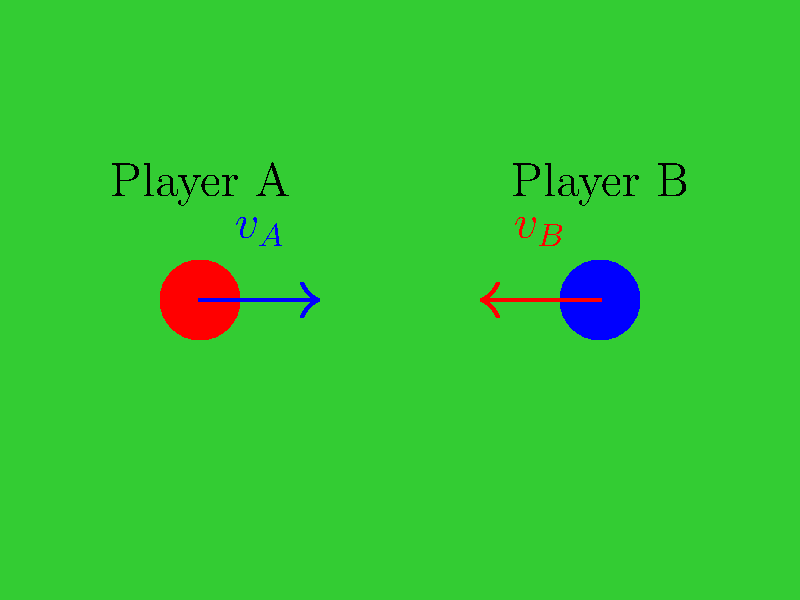Two soccer players, A and B, with masses $m_A = 70$ kg and $m_B = 80$ kg, are running towards each other on the field. Player A is moving with a velocity of $v_A = 5$ m/s to the right, while Player B is moving with a velocity of $v_B = 4$ m/s to the left. They collide and stick together. What is their combined velocity immediately after the collision? To solve this problem, we'll use the principle of conservation of momentum. The steps are as follows:

1) First, let's define the direction: right is positive, left is negative.

2) Calculate the initial momentum of each player:
   Player A: $p_A = m_A v_A = 70 \text{ kg} \times 5 \text{ m/s} = 350 \text{ kg}\cdot\text{m/s}$
   Player B: $p_B = m_B v_B = 80 \text{ kg} \times (-4 \text{ m/s}) = -320 \text{ kg}\cdot\text{m/s}$

3) Calculate the total initial momentum:
   $p_{total} = p_A + p_B = 350 \text{ kg}\cdot\text{m/s} + (-320 \text{ kg}\cdot\text{m/s}) = 30 \text{ kg}\cdot\text{m/s}$

4) After the collision, the players stick together, so their combined mass is:
   $m_{total} = m_A + m_B = 70 \text{ kg} + 80 \text{ kg} = 150 \text{ kg}$

5) Using the conservation of momentum, we know that the total momentum before and after the collision must be the same. So:
   $p_{total} = m_{total} v_{final}$

6) Solve for $v_{final}$:
   $v_{final} = \frac{p_{total}}{m_{total}} = \frac{30 \text{ kg}\cdot\text{m/s}}{150 \text{ kg}} = 0.2 \text{ m/s}$

Therefore, immediately after the collision, the players will move together to the right with a velocity of 0.2 m/s.
Answer: 0.2 m/s to the right 